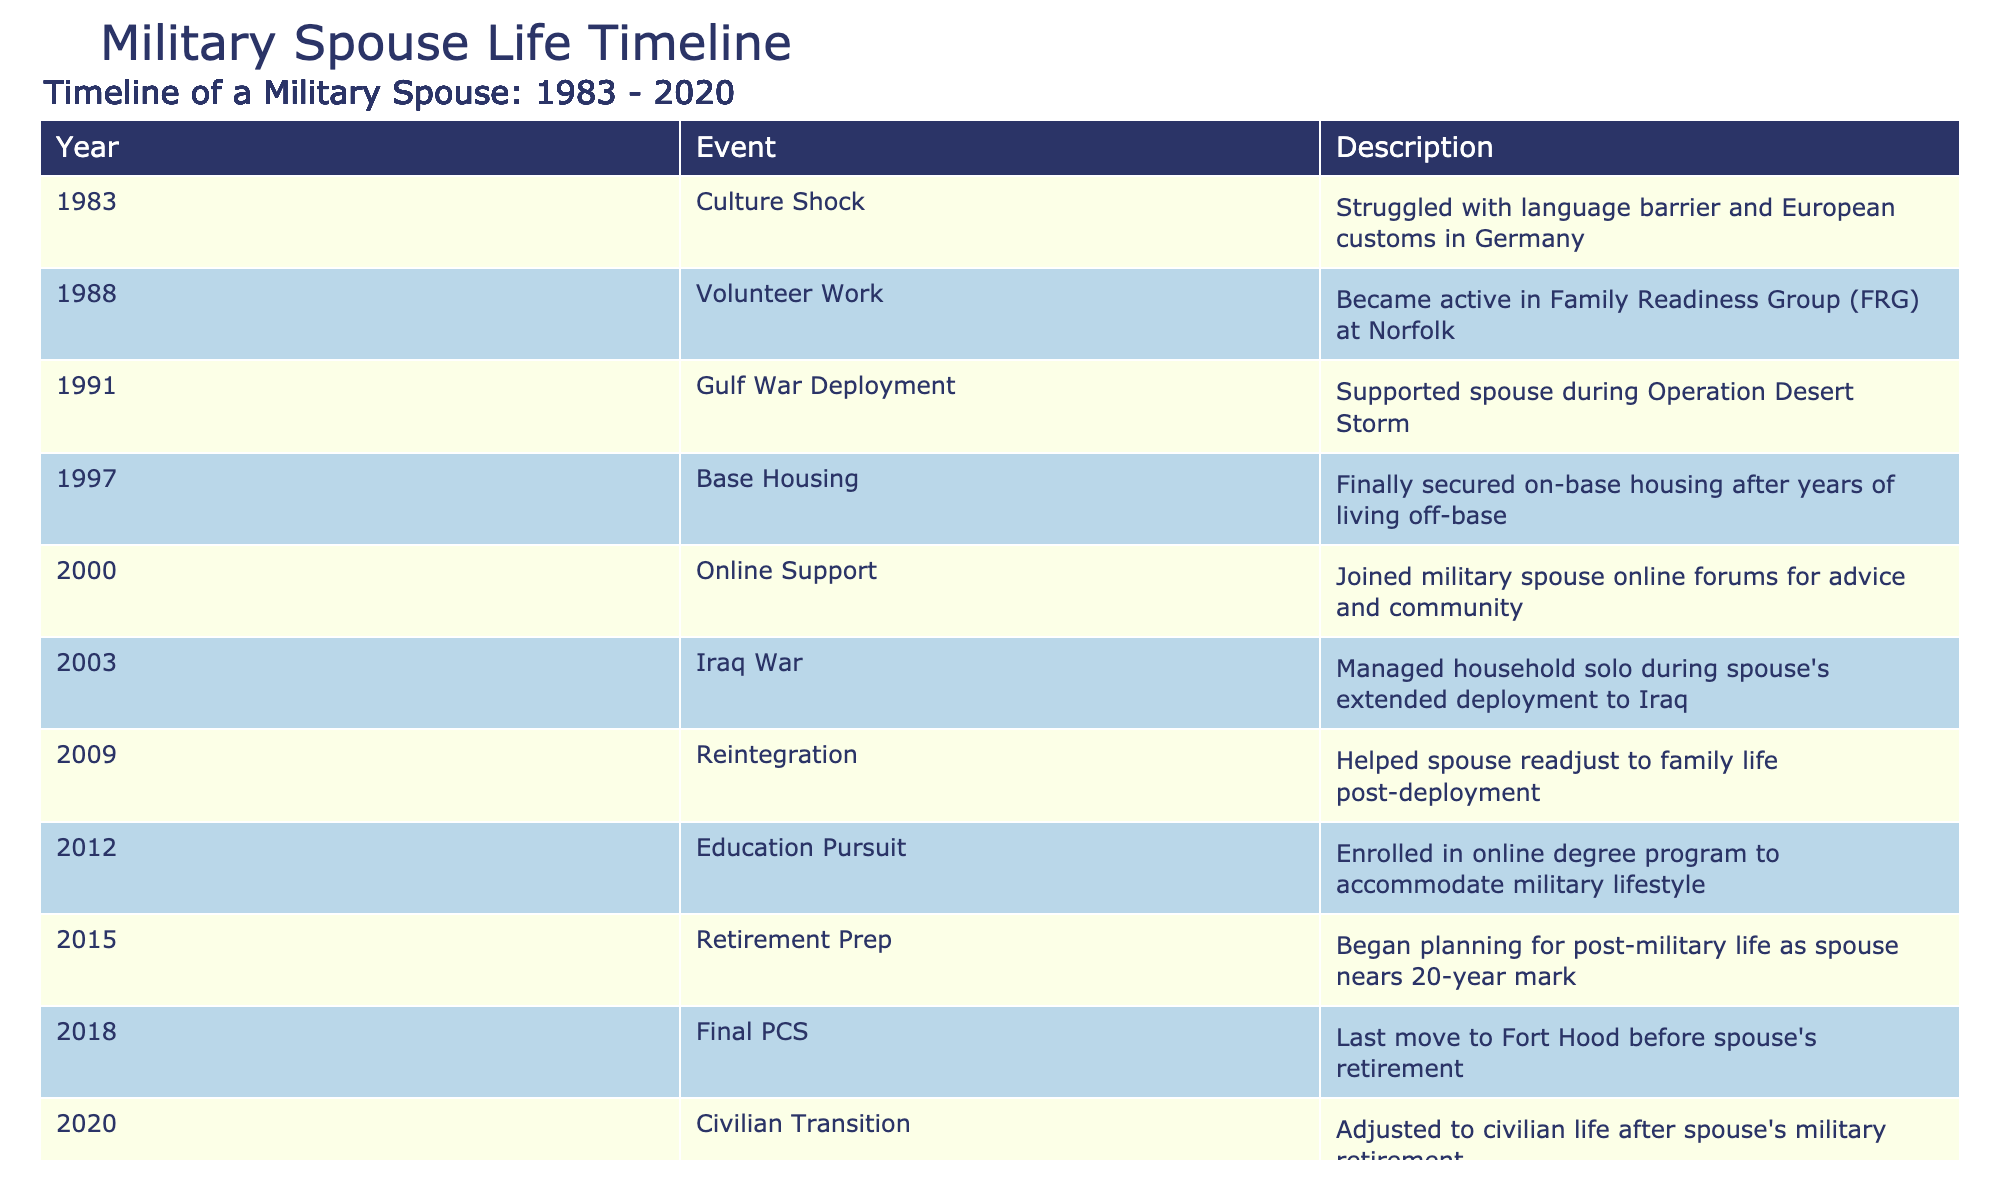What year did the spouse experience culture shock? According to the table, the event "Culture Shock" occurred in 1983.
Answer: 1983 Which event took place in 2003? The event that took place in 2003 was "Iraq War," during which the spouse managed household solo during the deployment.
Answer: Iraq War What was the first milestone related to active involvement in community? The first milestone related to active involvement in the community is "Volunteer Work" which happened in 1988 when the individual became active in the Family Readiness Group at Norfolk.
Answer: Volunteer Work Is it true that the spouse enrolled in an online degree program before the retirement prep began? Yes, it is true. The "Education Pursuit" milestone occurred in 2012, while "Retirement Prep" began in 2015. Therefore, the enrollment in the online degree program did happen before the retirement planning.
Answer: Yes How many years passed between the culture shock and the last move before retirement? The culture shock event occurred in 1983, and the last move before retirement happened in 2018. Calculating the years: 2018 - 1983 = 35 years.
Answer: 35 years What percentage of milestones are related to deployment events (Gulf War, Iraq War, Reintegration)? There are three deployment-related milestones: "Gulf War Deployment" in 1991, "Iraq War" in 2003, and "Reintegration" in 2009, out of a total of 10 events. The percentage is (3/10) * 100% = 30%.
Answer: 30% In what year did the spouse transition to civilian life after retirement? The spouse transitioned to civilian life in 2020, after the spouse's military retirement.
Answer: 2020 What were the major life changes noted from 1997 to 2018? During the period from 1997 to 2018, major life changes included securing on-base housing in 1997, taking on roles during deployments (2003 Iraq War), and moving for the last time before retirement in 2018.
Answer: Securing housing, managing deployments, last move before retirement 